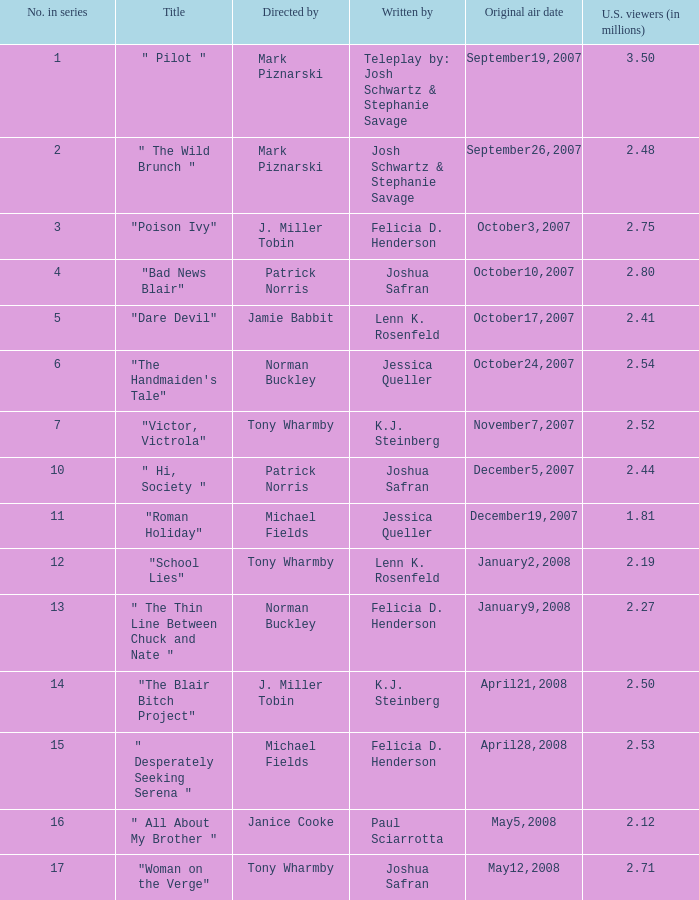80 as u.s. audience (in millions)? 1.0. 